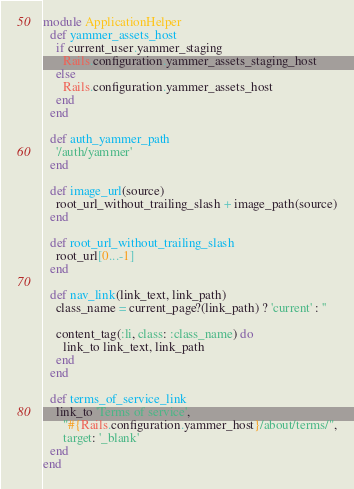<code> <loc_0><loc_0><loc_500><loc_500><_Ruby_>module ApplicationHelper
  def yammer_assets_host
    if current_user.yammer_staging
      Rails.configuration.yammer_assets_staging_host
    else
      Rails.configuration.yammer_assets_host
    end
  end

  def auth_yammer_path
    '/auth/yammer'
  end

  def image_url(source)
    root_url_without_trailing_slash + image_path(source)
  end

  def root_url_without_trailing_slash
    root_url[0...-1]
  end

  def nav_link(link_text, link_path)
    class_name = current_page?(link_path) ? 'current' : ''

    content_tag(:li, class: :class_name) do
      link_to link_text, link_path
    end
  end

  def terms_of_service_link
    link_to 'Terms of service',
      "#{Rails.configuration.yammer_host}/about/terms/",
      target: '_blank'
  end
end
</code> 